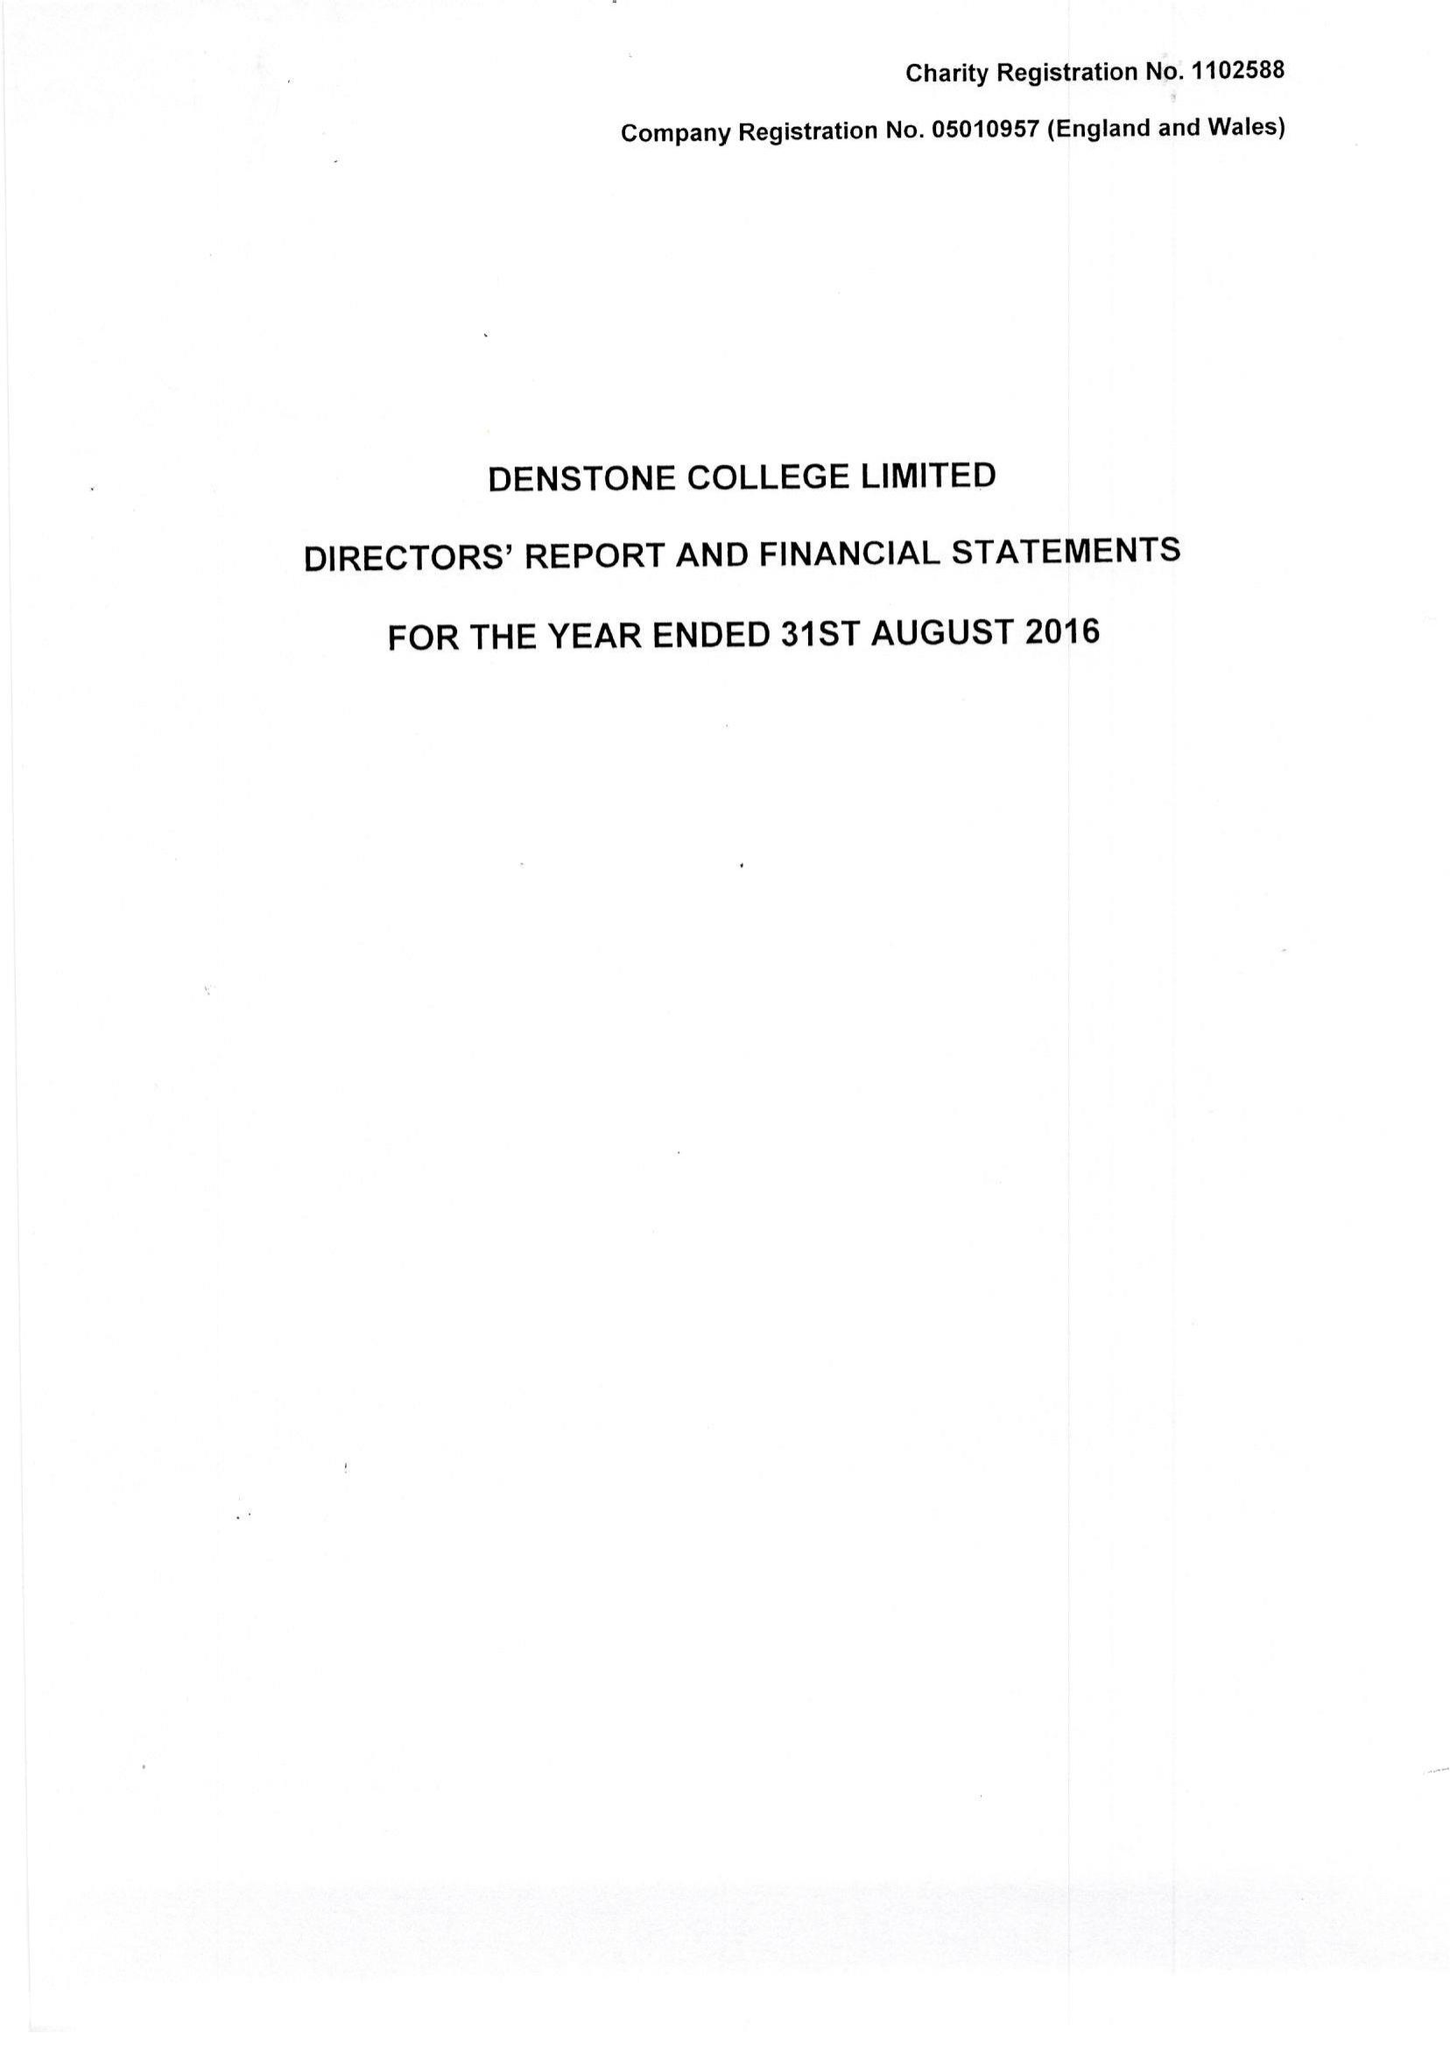What is the value for the address__post_town?
Answer the question using a single word or phrase. UTTOXETER 